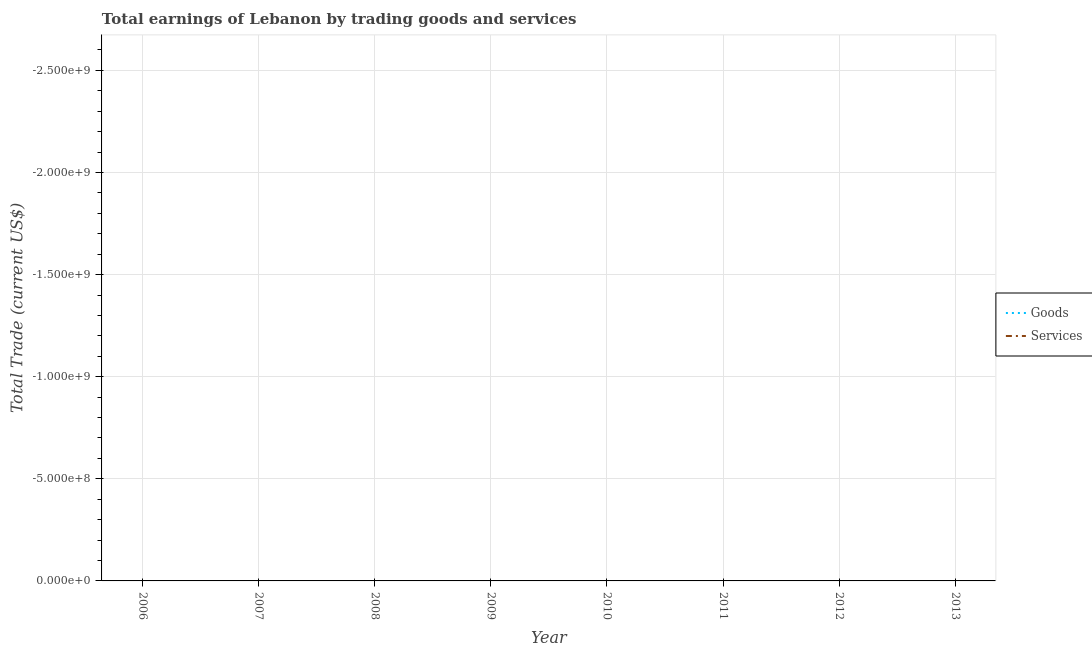How many different coloured lines are there?
Provide a succinct answer. 0. Does the line corresponding to amount earned by trading goods intersect with the line corresponding to amount earned by trading services?
Provide a short and direct response. No. Is the number of lines equal to the number of legend labels?
Offer a very short reply. No. What is the amount earned by trading goods in 2009?
Offer a terse response. 0. What is the total amount earned by trading services in the graph?
Your response must be concise. 0. What is the difference between the amount earned by trading goods in 2011 and the amount earned by trading services in 2012?
Your response must be concise. 0. What is the average amount earned by trading services per year?
Offer a terse response. 0. In how many years, is the amount earned by trading goods greater than the average amount earned by trading goods taken over all years?
Make the answer very short. 0. How many lines are there?
Your answer should be very brief. 0. How many years are there in the graph?
Your response must be concise. 8. Does the graph contain any zero values?
Your answer should be compact. Yes. Where does the legend appear in the graph?
Make the answer very short. Center right. How many legend labels are there?
Your response must be concise. 2. How are the legend labels stacked?
Your answer should be compact. Vertical. What is the title of the graph?
Keep it short and to the point. Total earnings of Lebanon by trading goods and services. What is the label or title of the Y-axis?
Your response must be concise. Total Trade (current US$). What is the Total Trade (current US$) of Services in 2006?
Keep it short and to the point. 0. What is the Total Trade (current US$) in Goods in 2007?
Ensure brevity in your answer.  0. What is the Total Trade (current US$) in Services in 2009?
Provide a short and direct response. 0. What is the Total Trade (current US$) of Services in 2010?
Your answer should be very brief. 0. What is the Total Trade (current US$) of Services in 2011?
Provide a short and direct response. 0. What is the Total Trade (current US$) of Goods in 2012?
Your answer should be compact. 0. What is the Total Trade (current US$) in Goods in 2013?
Provide a short and direct response. 0. What is the total Total Trade (current US$) of Services in the graph?
Offer a very short reply. 0. What is the average Total Trade (current US$) of Services per year?
Your answer should be very brief. 0. 